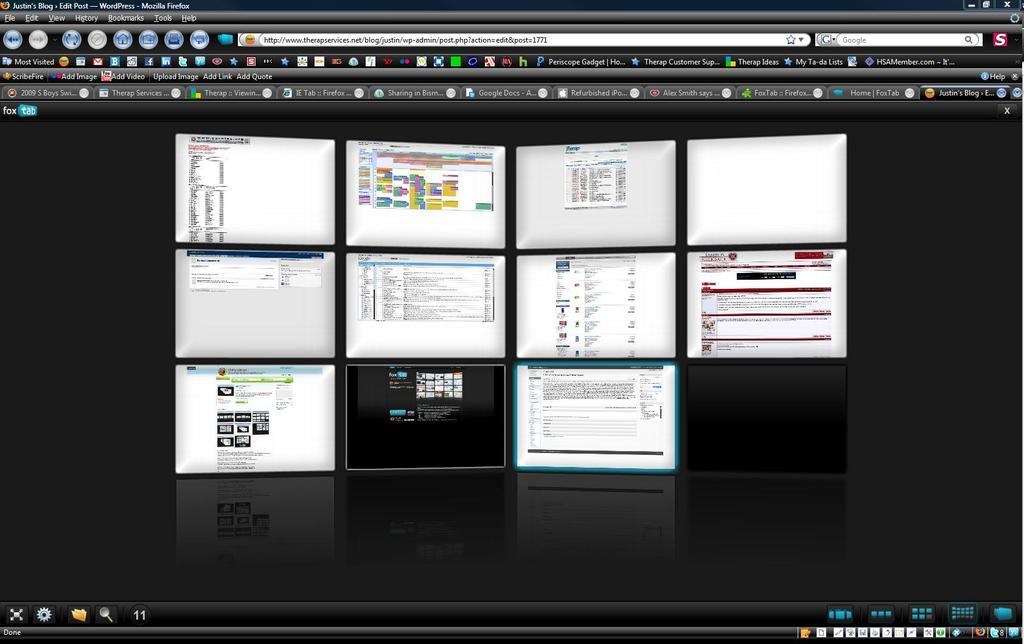<image>
Provide a brief description of the given image. Multiple tabs are open on a computer screen such as ScribeFire. 